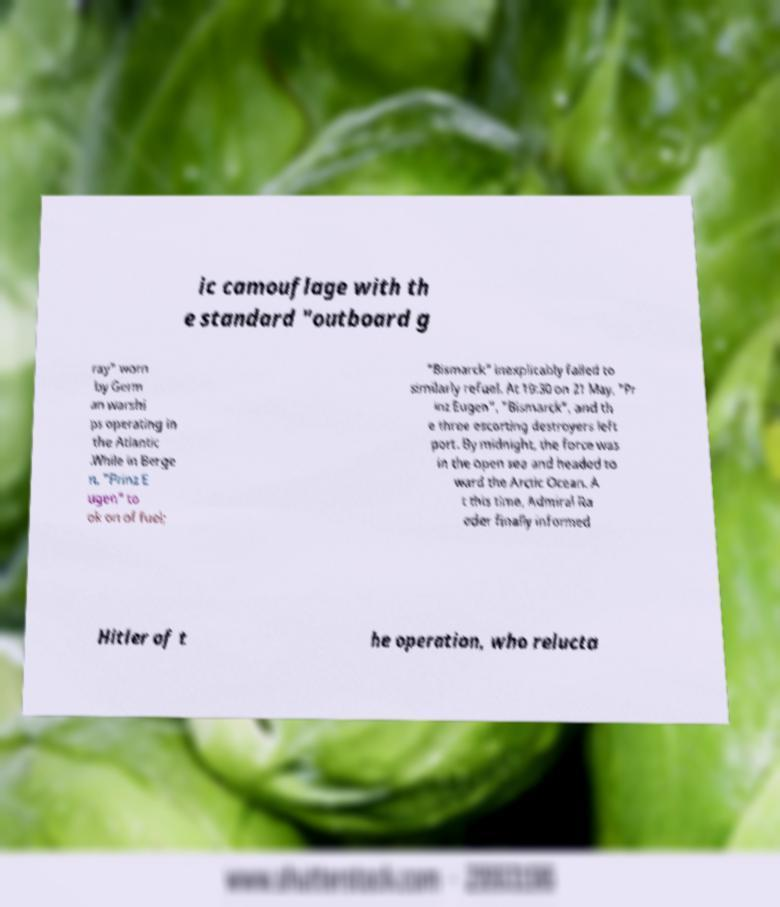Can you accurately transcribe the text from the provided image for me? ic camouflage with th e standard "outboard g ray" worn by Germ an warshi ps operating in the Atlantic .While in Berge n, "Prinz E ugen" to ok on of fuel; "Bismarck" inexplicably failed to similarly refuel. At 19:30 on 21 May, "Pr inz Eugen", "Bismarck", and th e three escorting destroyers left port. By midnight, the force was in the open sea and headed to ward the Arctic Ocean. A t this time, Admiral Ra eder finally informed Hitler of t he operation, who relucta 